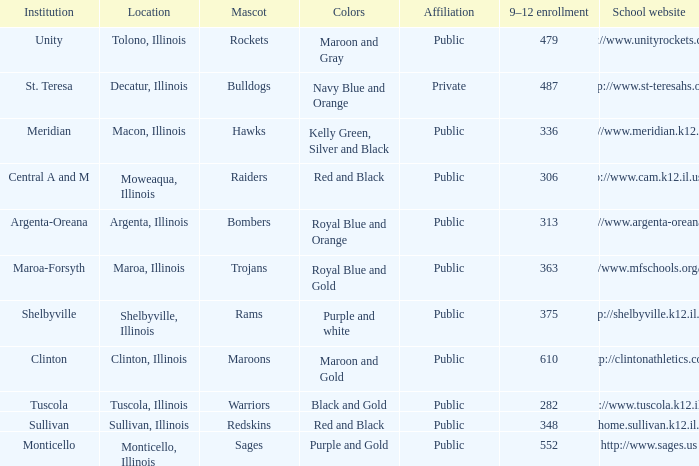What location has 363 students enrolled in the 9th to 12th grades? Maroa, Illinois. 